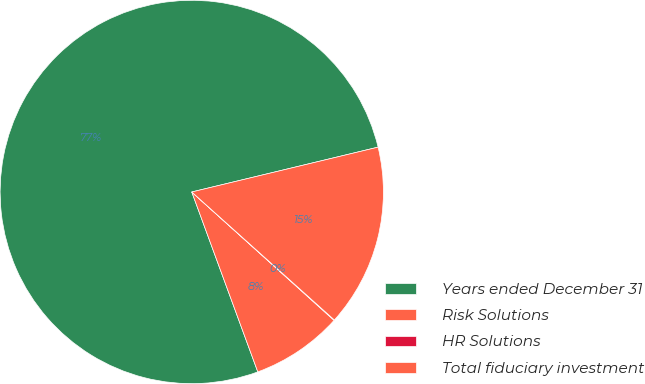Convert chart to OTSL. <chart><loc_0><loc_0><loc_500><loc_500><pie_chart><fcel>Years ended December 31<fcel>Risk Solutions<fcel>HR Solutions<fcel>Total fiduciary investment<nl><fcel>76.84%<fcel>7.72%<fcel>0.04%<fcel>15.4%<nl></chart> 